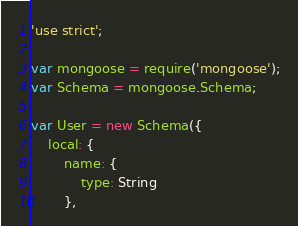<code> <loc_0><loc_0><loc_500><loc_500><_JavaScript_>'use strict';

var mongoose = require('mongoose');
var Schema = mongoose.Schema;

var User = new Schema({
    local: {
        name: {
            type: String
        },</code> 